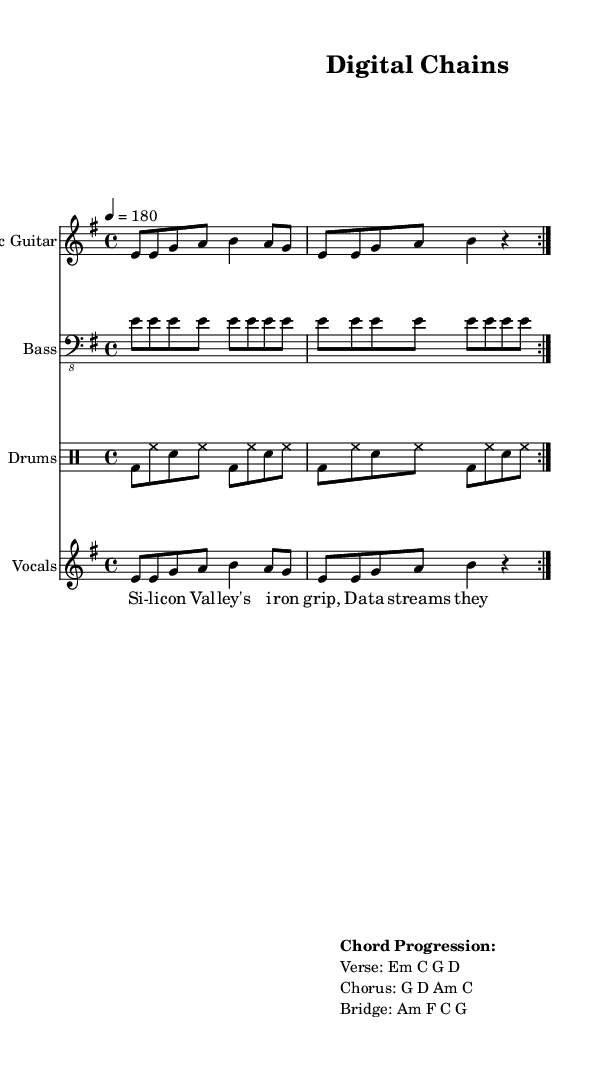What is the key signature of this music? The key signature indicates E minor, which has one sharp (F#). This is derived from the global music information section that specifies key signature as "e \minor".
Answer: E minor What is the time signature of this piece? The time signature is identified through the global section where it states "4/4", indicating four beats per measure, with each beat represented by a quarter note.
Answer: 4/4 What is the tempo marking of this score? The tempo marking of the music is indicated in the global section as "4 = 180", meaning there are 180 beats per minute, specifying a fast tempo.
Answer: 180 What is the chord progression for the verse? The chord progression for the verse can be found in the markup section where it explicitly lists "Verse: Em C G D", indicating the chords used.
Answer: Em C G D What instrument plays the bass part? The bass part is labeled clearly with the instrument name "Bass" in the staff title, which denotes that this part is meant to be played by a bass guitar.
Answer: Bass What lyrical themes are present in the vocals? The lyrics, “Silicon Valley's iron grip, Data streams they love to sip,” suggest themes of corporate control and critique of technology, which is a common punk theme addressing societal issues.
Answer: Corporate control How many measures are repeated in the electric guitar and drum parts? Both the electric guitar and drum parts have a repeat sign indicated with "volta 2", which shows that each section is played twice, leading to a total of 2 measures repeated.
Answer: 2 